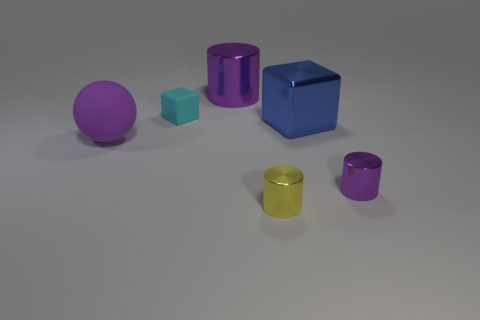Add 2 big purple rubber balls. How many objects exist? 8 Subtract all spheres. How many objects are left? 5 Subtract 1 purple spheres. How many objects are left? 5 Subtract all big purple rubber things. Subtract all brown metallic things. How many objects are left? 5 Add 4 large metal cylinders. How many large metal cylinders are left? 5 Add 5 yellow things. How many yellow things exist? 6 